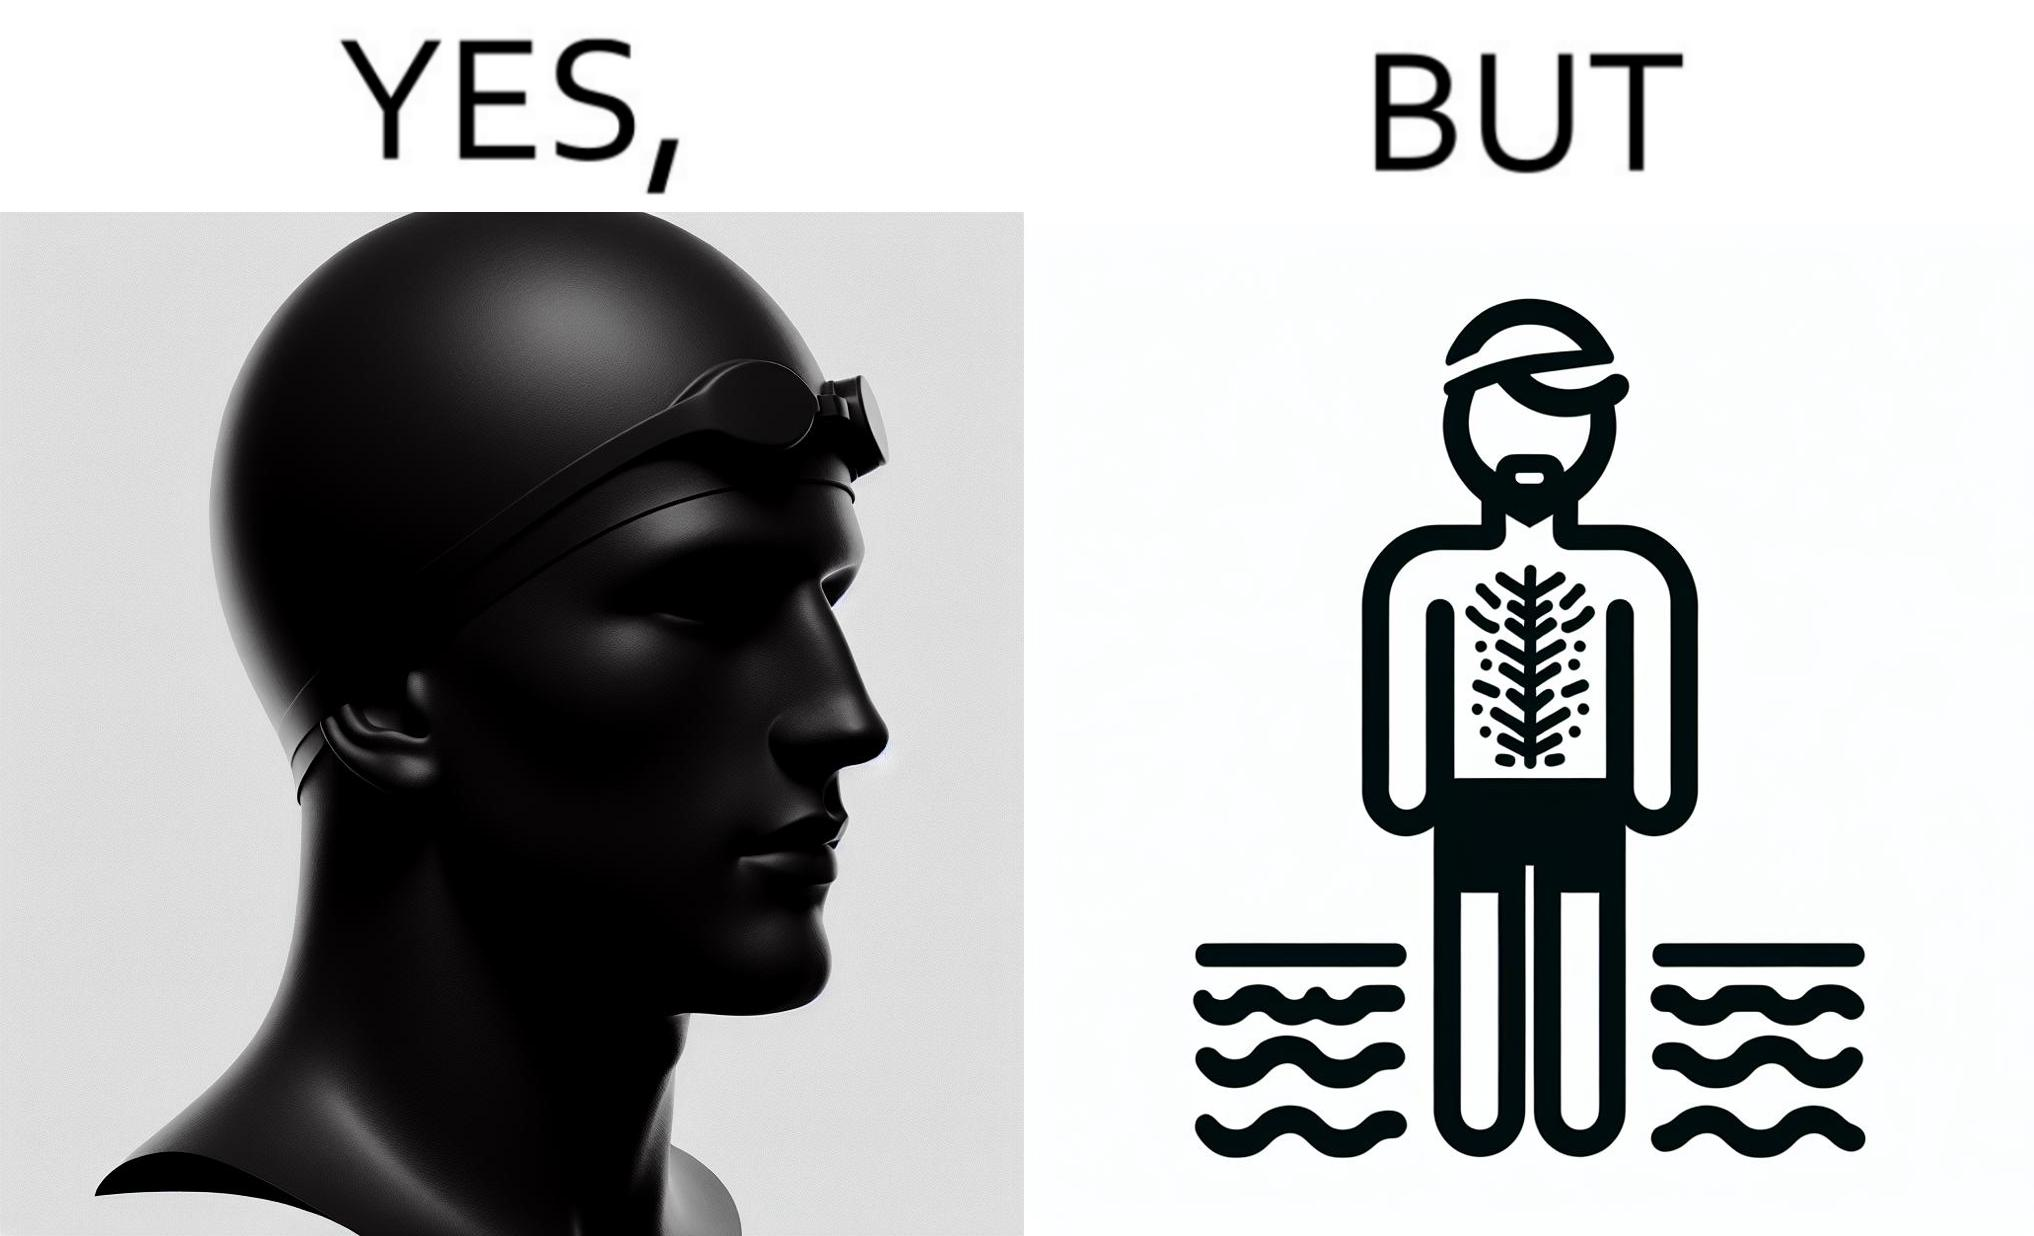Is there satirical content in this image? Yes, this image is satirical. 